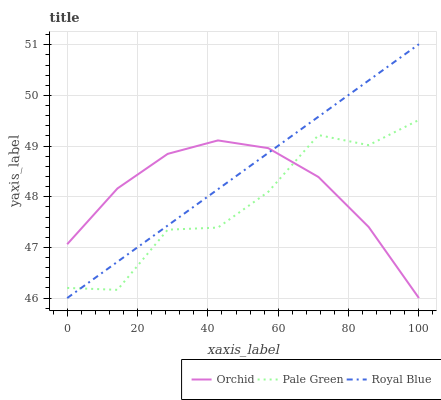Does Pale Green have the minimum area under the curve?
Answer yes or no. Yes. Does Royal Blue have the maximum area under the curve?
Answer yes or no. Yes. Does Orchid have the minimum area under the curve?
Answer yes or no. No. Does Orchid have the maximum area under the curve?
Answer yes or no. No. Is Royal Blue the smoothest?
Answer yes or no. Yes. Is Pale Green the roughest?
Answer yes or no. Yes. Is Orchid the smoothest?
Answer yes or no. No. Is Orchid the roughest?
Answer yes or no. No. Does Pale Green have the lowest value?
Answer yes or no. No. Does Royal Blue have the highest value?
Answer yes or no. Yes. Does Pale Green have the highest value?
Answer yes or no. No. Does Orchid intersect Royal Blue?
Answer yes or no. Yes. Is Orchid less than Royal Blue?
Answer yes or no. No. Is Orchid greater than Royal Blue?
Answer yes or no. No. 